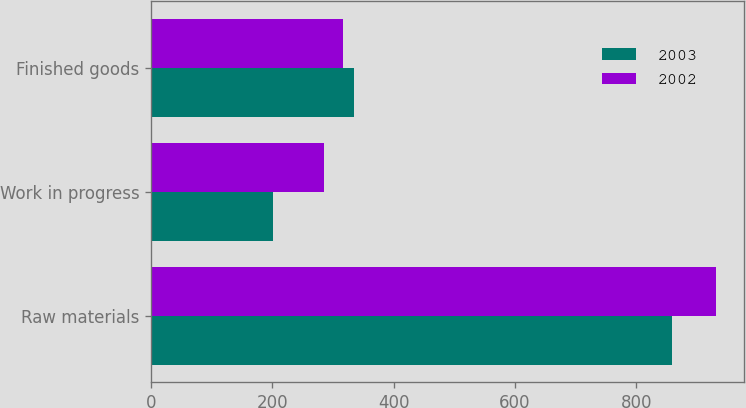Convert chart to OTSL. <chart><loc_0><loc_0><loc_500><loc_500><stacked_bar_chart><ecel><fcel>Raw materials<fcel>Work in progress<fcel>Finished goods<nl><fcel>2003<fcel>859<fcel>201<fcel>335<nl><fcel>2002<fcel>931<fcel>285<fcel>317<nl></chart> 